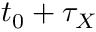<formula> <loc_0><loc_0><loc_500><loc_500>t _ { 0 } + \tau _ { X }</formula> 